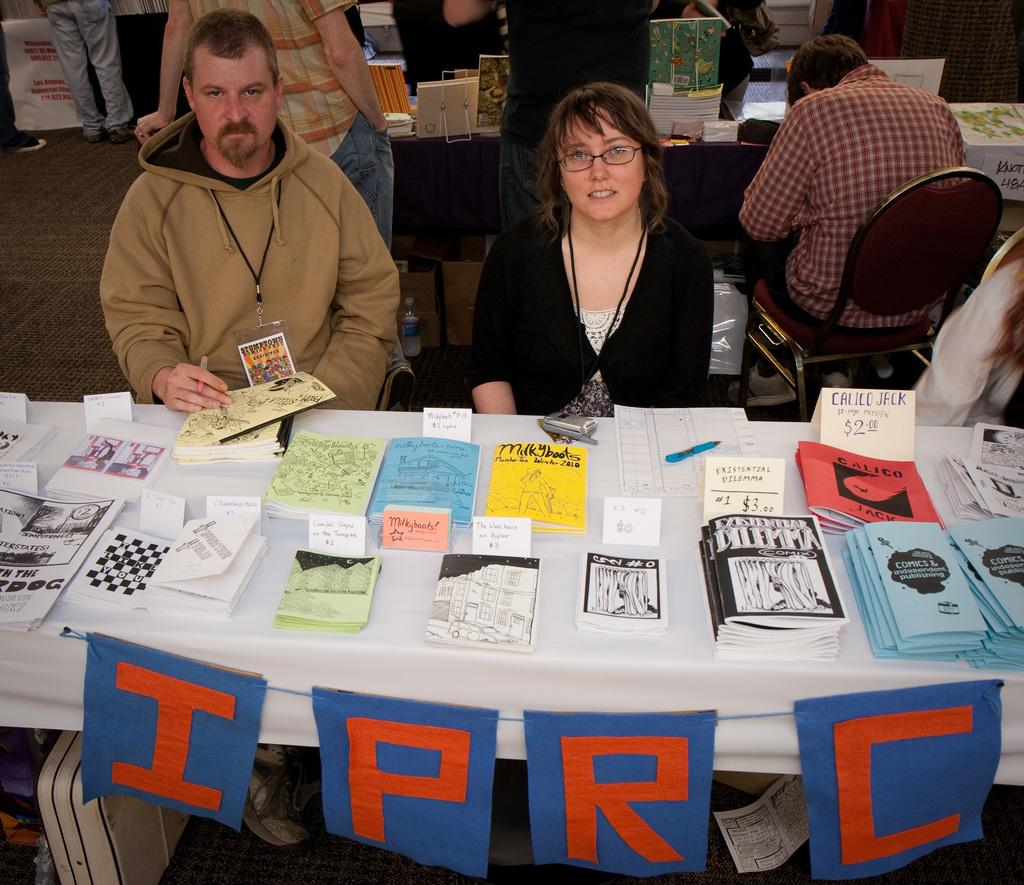What are the people in the image doing? The people in the image are sitting on chairs. What objects are present in the image that the people might be using? Tables are present in the image. What can be seen on top of the tables? Stationary is on the tables in the image. How many toes can be seen on the people in the image? There is no way to determine the number of toes visible on the people in the image, as feet are not shown. 